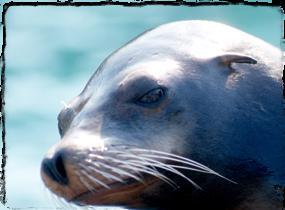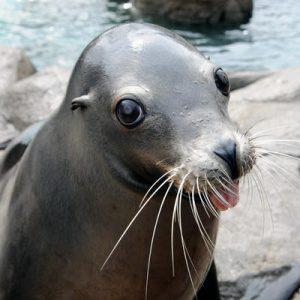The first image is the image on the left, the second image is the image on the right. Given the left and right images, does the statement "At least one seal is eating a fish." hold true? Answer yes or no. No. The first image is the image on the left, the second image is the image on the right. Given the left and right images, does the statement "The right image shows a seal with a fish held in its mouth." hold true? Answer yes or no. No. 